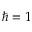<formula> <loc_0><loc_0><loc_500><loc_500>\hbar { = } 1</formula> 